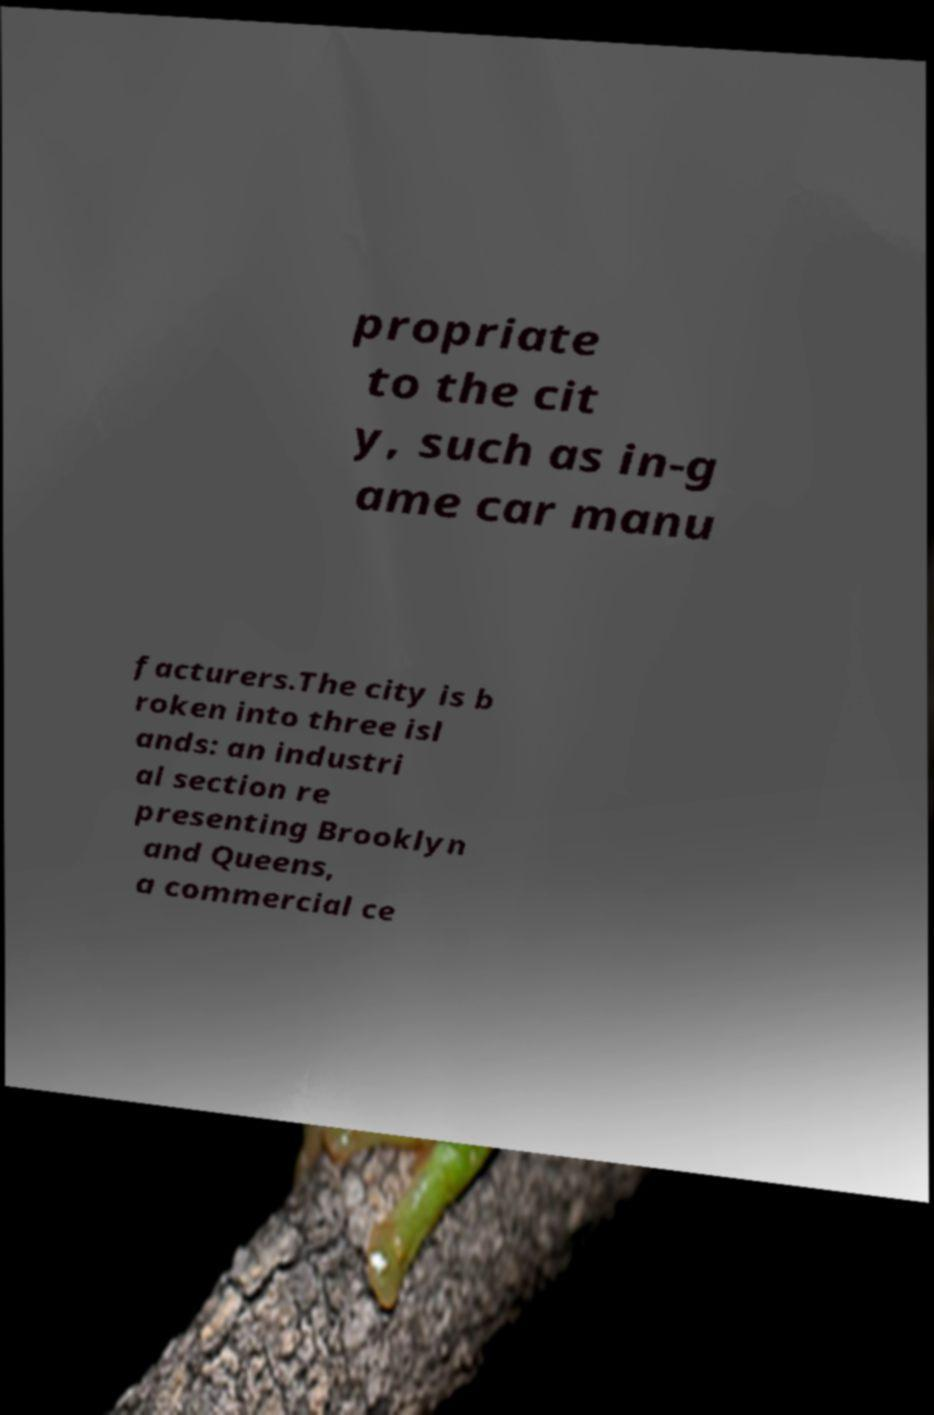For documentation purposes, I need the text within this image transcribed. Could you provide that? propriate to the cit y, such as in-g ame car manu facturers.The city is b roken into three isl ands: an industri al section re presenting Brooklyn and Queens, a commercial ce 